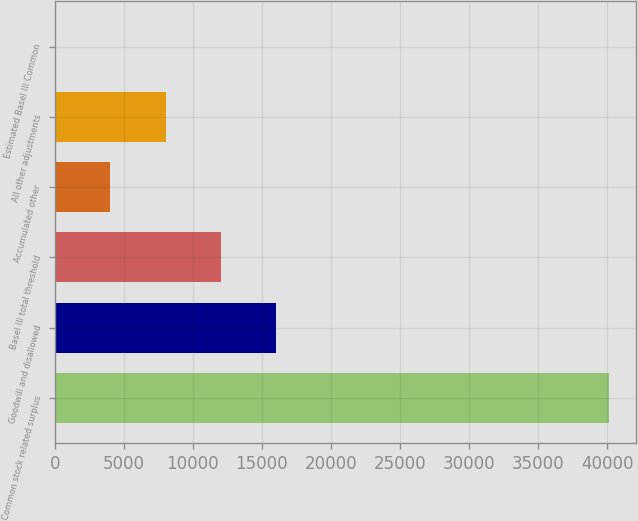<chart> <loc_0><loc_0><loc_500><loc_500><bar_chart><fcel>Common stock related surplus<fcel>Goodwill and disallowed<fcel>Basel III total threshold<fcel>Accumulated other<fcel>All other adjustments<fcel>Estimated Basel III Common<nl><fcel>40103<fcel>16047.7<fcel>12038.5<fcel>4020.11<fcel>8029.32<fcel>10.9<nl></chart> 